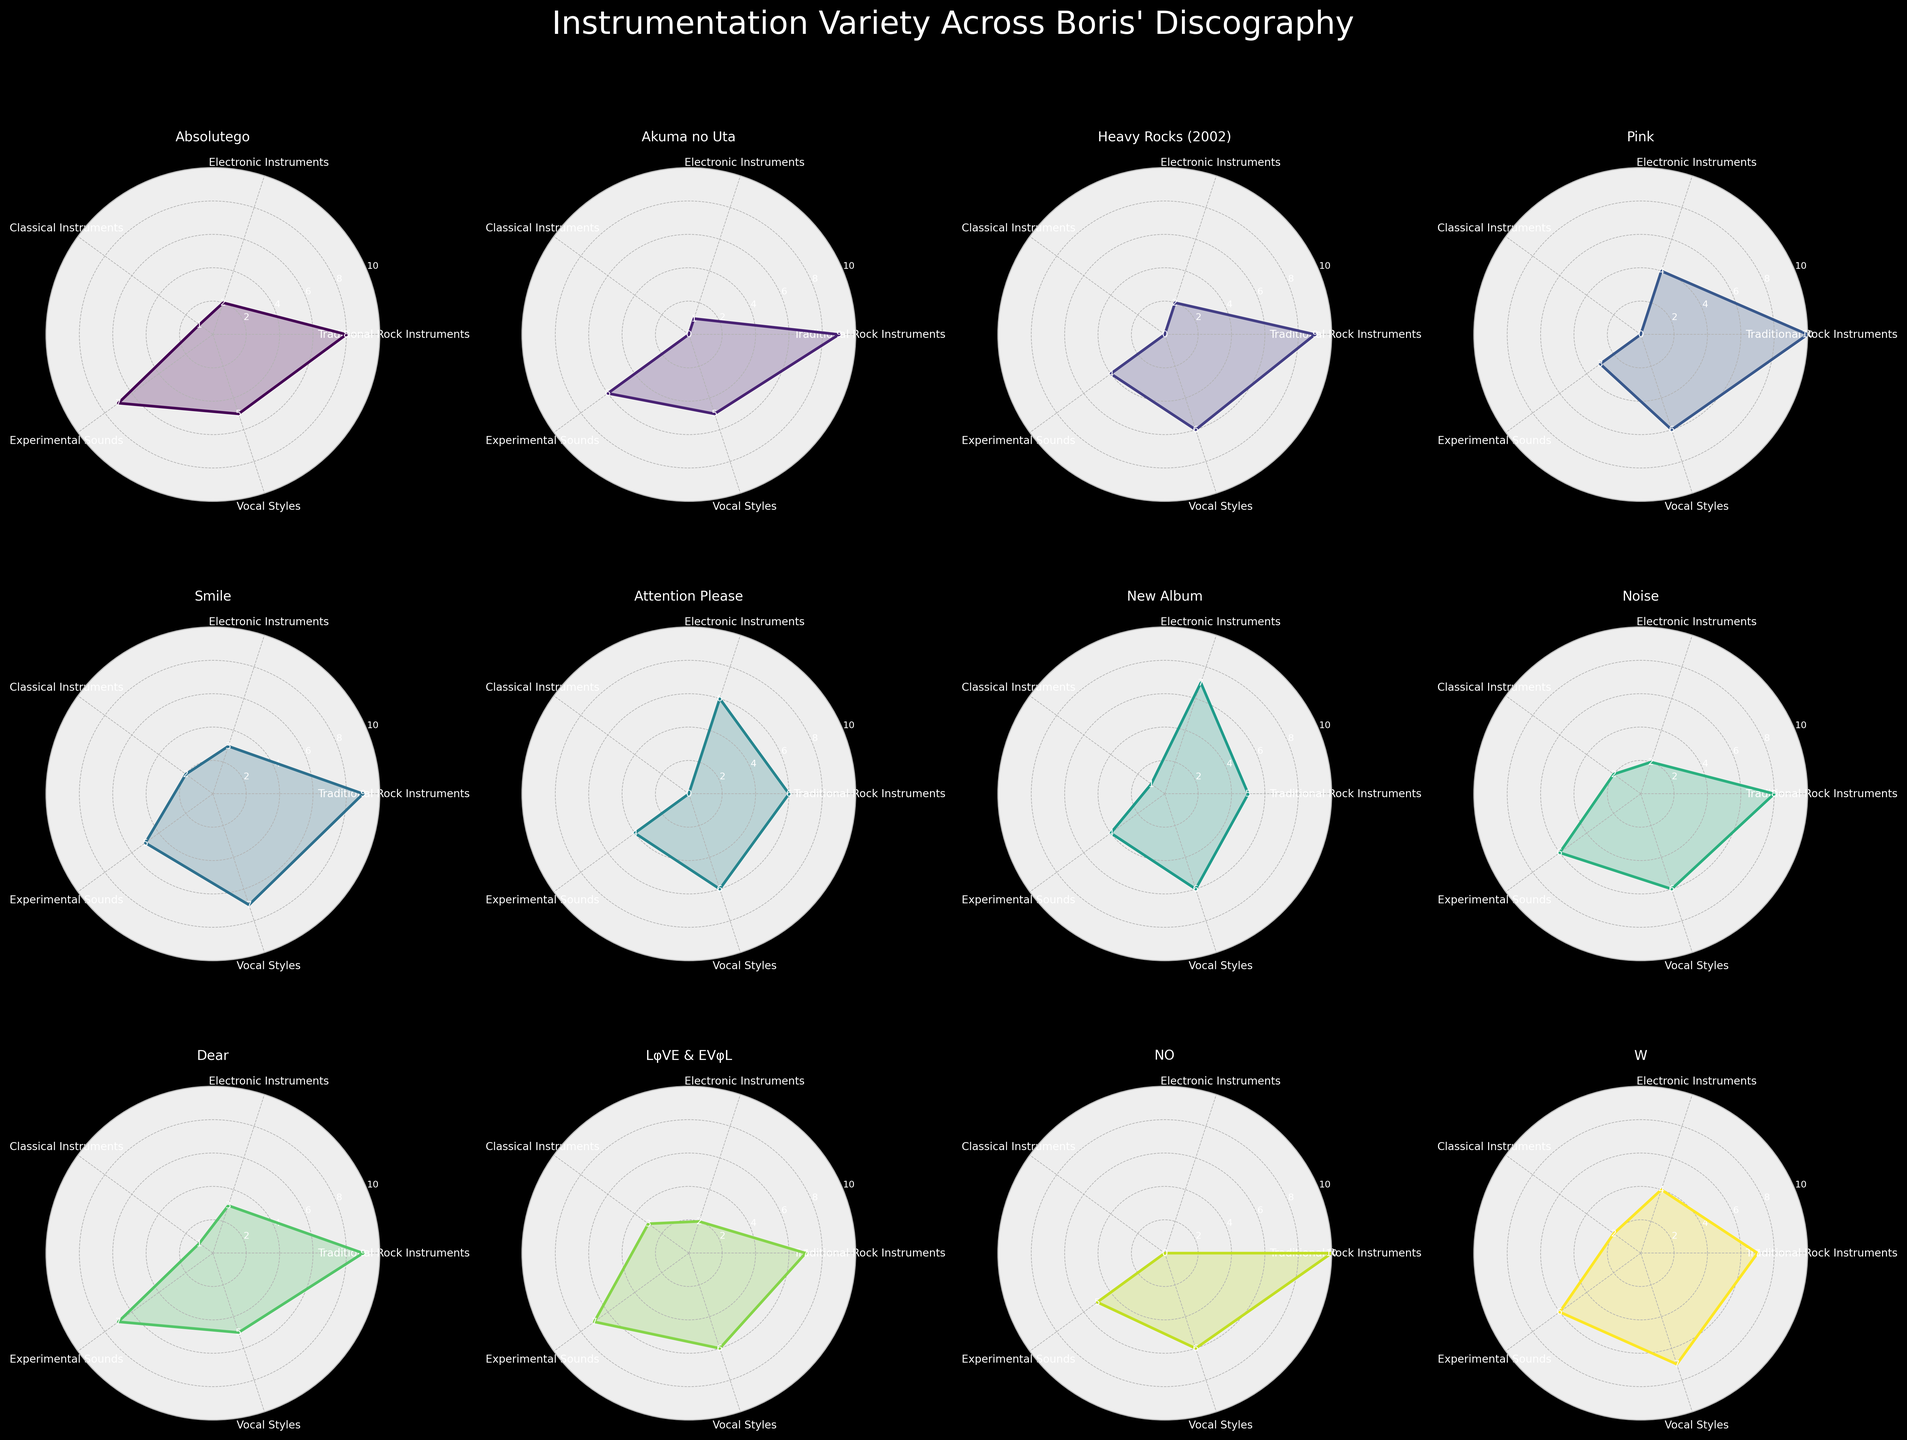How many albums show usage of Classical Instruments? By examining each subplot and counting those with non-zero values in the Classical Instruments category, we see that "Smile," "Noise," "LφVE & EVφL," and "W" include classical instruments.
Answer: 4 Which album has the highest score in Traditional Rock Instruments and what is the score? Look at the Traditional Rock Instruments axis for all the subplots and identify the highest value, which is 10 for the album "Pink" and "NO".
Answer: Pink, NO (10) What is the average score of Electronic Instruments across all albums? Sum the values in the Electronic Instruments category for all albums and then divide by the number of albums. The sum is (2+1+2+4+3+6+7+2+3+2+0+4) = 36, and there are 12 albums, so the average is 36/12 = 3.
Answer: 3 Which album exhibits the highest variety in instrumentation based on the subplot appearances? By visually inspecting the radar charts, "New Album" has the highest scores distributed across multiple categories, indicating a high variety in instrumentation.
Answer: New Album Of the albums, which has the most even distribution across all instrumentation types? Look for the radar chart that forms the most balanced shape across all axes. "W" appears to have one of the most evenly distributed shapes.
Answer: W Among "Absolutego" and "Dear," which uses more Experimental Sounds? Check the Experimental Sounds axis for both "Absolutego" and "Dear." "Absolutego" has a higher score (7) compared to "Dear" (7).
Answer: Absolutego Is there any album that has a zero score in Classical Instruments? Check the Classical Instruments axis in each subplot. Several albums show zero scores, including "Akuma no Uta," "Heavy Rocks (2002)," "Pink," "Attention Please," and "NO".
Answer: Yes Which album features the widest range in Vocal Styles? By observing the height of the Vocal Styles axis for all albums, "Smile" and "W" both have one of the broader ranges (7).
Answer: Smile, W Calculate the total score of Traditional Rock Instruments for "Pink" and "Love & Evol" combined. Add the Traditional Rock Instruments scores for both "Pink" (10) and "Love & Evol" (7). The total is 10 + 7 = 17.
Answer: 17 Which album scores the highest in Experimental Sounds and also uses Electronic Instruments? Compare scores in Experimental Sounds between subplots while confirming non-zero Electronic Instruments value. "Absolutego" scores highest in Experimental Sounds (7) with Electronic Instruments (2).
Answer: Absolutego 